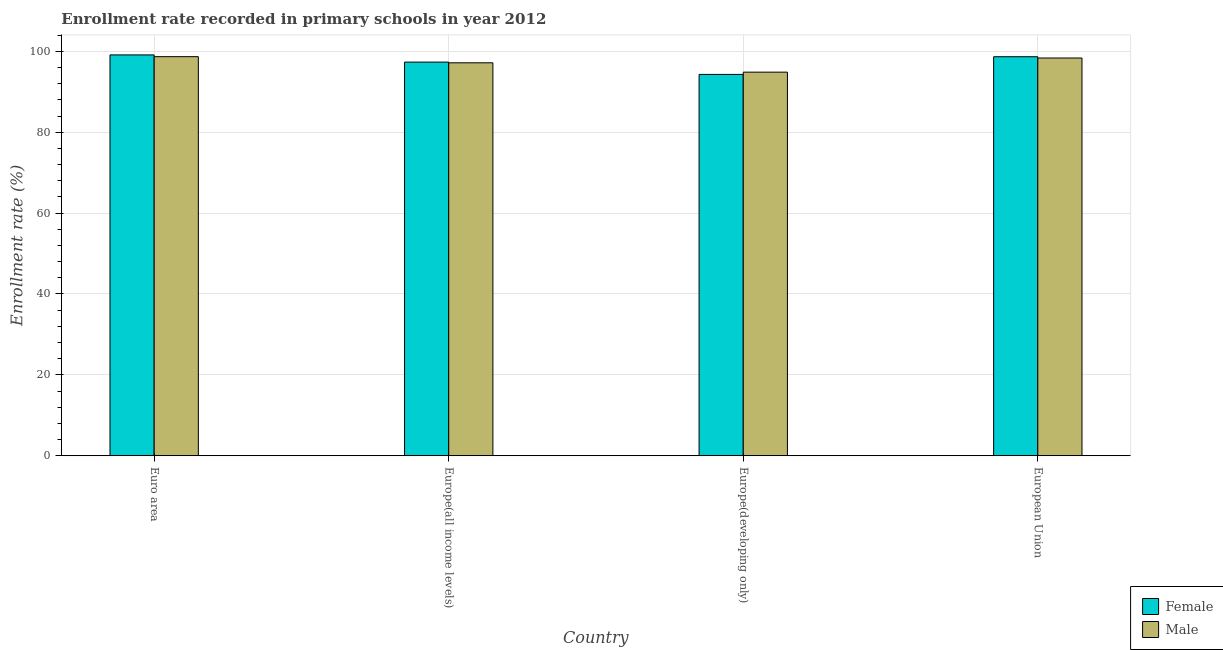How many different coloured bars are there?
Provide a succinct answer. 2. How many groups of bars are there?
Offer a terse response. 4. Are the number of bars per tick equal to the number of legend labels?
Your answer should be compact. Yes. How many bars are there on the 4th tick from the left?
Provide a succinct answer. 2. How many bars are there on the 2nd tick from the right?
Provide a short and direct response. 2. What is the label of the 2nd group of bars from the left?
Provide a short and direct response. Europe(all income levels). What is the enrollment rate of female students in Europe(all income levels)?
Make the answer very short. 97.34. Across all countries, what is the maximum enrollment rate of male students?
Your response must be concise. 98.68. Across all countries, what is the minimum enrollment rate of female students?
Your answer should be very brief. 94.29. In which country was the enrollment rate of female students minimum?
Your answer should be very brief. Europe(developing only). What is the total enrollment rate of female students in the graph?
Ensure brevity in your answer.  389.42. What is the difference between the enrollment rate of female students in Euro area and that in Europe(all income levels)?
Offer a very short reply. 1.78. What is the difference between the enrollment rate of male students in European Union and the enrollment rate of female students in Europe(all income levels)?
Your answer should be very brief. 1.01. What is the average enrollment rate of female students per country?
Your answer should be compact. 97.35. What is the difference between the enrollment rate of male students and enrollment rate of female students in Europe(developing only)?
Give a very brief answer. 0.56. What is the ratio of the enrollment rate of female students in Europe(all income levels) to that in Europe(developing only)?
Give a very brief answer. 1.03. Is the difference between the enrollment rate of female students in Euro area and Europe(developing only) greater than the difference between the enrollment rate of male students in Euro area and Europe(developing only)?
Keep it short and to the point. Yes. What is the difference between the highest and the second highest enrollment rate of female students?
Your answer should be very brief. 0.45. What is the difference between the highest and the lowest enrollment rate of female students?
Your answer should be very brief. 4.82. How many bars are there?
Make the answer very short. 8. Are all the bars in the graph horizontal?
Your response must be concise. No. How many countries are there in the graph?
Offer a terse response. 4. How many legend labels are there?
Ensure brevity in your answer.  2. What is the title of the graph?
Your answer should be very brief. Enrollment rate recorded in primary schools in year 2012. Does "Subsidies" appear as one of the legend labels in the graph?
Give a very brief answer. No. What is the label or title of the Y-axis?
Give a very brief answer. Enrollment rate (%). What is the Enrollment rate (%) of Female in Euro area?
Make the answer very short. 99.12. What is the Enrollment rate (%) in Male in Euro area?
Keep it short and to the point. 98.68. What is the Enrollment rate (%) of Female in Europe(all income levels)?
Your answer should be very brief. 97.34. What is the Enrollment rate (%) of Male in Europe(all income levels)?
Make the answer very short. 97.16. What is the Enrollment rate (%) in Female in Europe(developing only)?
Give a very brief answer. 94.29. What is the Enrollment rate (%) of Male in Europe(developing only)?
Your response must be concise. 94.85. What is the Enrollment rate (%) of Female in European Union?
Your answer should be very brief. 98.67. What is the Enrollment rate (%) in Male in European Union?
Keep it short and to the point. 98.35. Across all countries, what is the maximum Enrollment rate (%) of Female?
Your answer should be compact. 99.12. Across all countries, what is the maximum Enrollment rate (%) of Male?
Provide a short and direct response. 98.68. Across all countries, what is the minimum Enrollment rate (%) in Female?
Keep it short and to the point. 94.29. Across all countries, what is the minimum Enrollment rate (%) in Male?
Provide a short and direct response. 94.85. What is the total Enrollment rate (%) of Female in the graph?
Make the answer very short. 389.42. What is the total Enrollment rate (%) in Male in the graph?
Offer a terse response. 389.05. What is the difference between the Enrollment rate (%) of Female in Euro area and that in Europe(all income levels)?
Ensure brevity in your answer.  1.78. What is the difference between the Enrollment rate (%) of Male in Euro area and that in Europe(all income levels)?
Provide a short and direct response. 1.52. What is the difference between the Enrollment rate (%) in Female in Euro area and that in Europe(developing only)?
Keep it short and to the point. 4.82. What is the difference between the Enrollment rate (%) of Male in Euro area and that in Europe(developing only)?
Provide a short and direct response. 3.83. What is the difference between the Enrollment rate (%) in Female in Euro area and that in European Union?
Offer a very short reply. 0.45. What is the difference between the Enrollment rate (%) in Male in Euro area and that in European Union?
Provide a short and direct response. 0.33. What is the difference between the Enrollment rate (%) of Female in Europe(all income levels) and that in Europe(developing only)?
Offer a very short reply. 3.05. What is the difference between the Enrollment rate (%) in Male in Europe(all income levels) and that in Europe(developing only)?
Ensure brevity in your answer.  2.31. What is the difference between the Enrollment rate (%) in Female in Europe(all income levels) and that in European Union?
Offer a terse response. -1.33. What is the difference between the Enrollment rate (%) in Male in Europe(all income levels) and that in European Union?
Give a very brief answer. -1.19. What is the difference between the Enrollment rate (%) in Female in Europe(developing only) and that in European Union?
Make the answer very short. -4.38. What is the difference between the Enrollment rate (%) in Male in Europe(developing only) and that in European Union?
Your answer should be compact. -3.5. What is the difference between the Enrollment rate (%) of Female in Euro area and the Enrollment rate (%) of Male in Europe(all income levels)?
Your answer should be compact. 1.95. What is the difference between the Enrollment rate (%) of Female in Euro area and the Enrollment rate (%) of Male in Europe(developing only)?
Your answer should be compact. 4.26. What is the difference between the Enrollment rate (%) of Female in Euro area and the Enrollment rate (%) of Male in European Union?
Your answer should be compact. 0.76. What is the difference between the Enrollment rate (%) of Female in Europe(all income levels) and the Enrollment rate (%) of Male in Europe(developing only)?
Provide a short and direct response. 2.49. What is the difference between the Enrollment rate (%) of Female in Europe(all income levels) and the Enrollment rate (%) of Male in European Union?
Provide a succinct answer. -1.01. What is the difference between the Enrollment rate (%) in Female in Europe(developing only) and the Enrollment rate (%) in Male in European Union?
Offer a terse response. -4.06. What is the average Enrollment rate (%) in Female per country?
Ensure brevity in your answer.  97.35. What is the average Enrollment rate (%) in Male per country?
Your answer should be compact. 97.26. What is the difference between the Enrollment rate (%) in Female and Enrollment rate (%) in Male in Euro area?
Keep it short and to the point. 0.43. What is the difference between the Enrollment rate (%) of Female and Enrollment rate (%) of Male in Europe(all income levels)?
Your answer should be compact. 0.18. What is the difference between the Enrollment rate (%) in Female and Enrollment rate (%) in Male in Europe(developing only)?
Provide a succinct answer. -0.56. What is the difference between the Enrollment rate (%) of Female and Enrollment rate (%) of Male in European Union?
Your answer should be very brief. 0.32. What is the ratio of the Enrollment rate (%) of Female in Euro area to that in Europe(all income levels)?
Offer a terse response. 1.02. What is the ratio of the Enrollment rate (%) of Male in Euro area to that in Europe(all income levels)?
Provide a succinct answer. 1.02. What is the ratio of the Enrollment rate (%) in Female in Euro area to that in Europe(developing only)?
Offer a very short reply. 1.05. What is the ratio of the Enrollment rate (%) of Male in Euro area to that in Europe(developing only)?
Give a very brief answer. 1.04. What is the ratio of the Enrollment rate (%) in Female in Euro area to that in European Union?
Your answer should be compact. 1. What is the ratio of the Enrollment rate (%) of Male in Euro area to that in European Union?
Offer a terse response. 1. What is the ratio of the Enrollment rate (%) in Female in Europe(all income levels) to that in Europe(developing only)?
Ensure brevity in your answer.  1.03. What is the ratio of the Enrollment rate (%) of Male in Europe(all income levels) to that in Europe(developing only)?
Your answer should be compact. 1.02. What is the ratio of the Enrollment rate (%) in Female in Europe(all income levels) to that in European Union?
Provide a succinct answer. 0.99. What is the ratio of the Enrollment rate (%) of Male in Europe(all income levels) to that in European Union?
Ensure brevity in your answer.  0.99. What is the ratio of the Enrollment rate (%) of Female in Europe(developing only) to that in European Union?
Your response must be concise. 0.96. What is the ratio of the Enrollment rate (%) of Male in Europe(developing only) to that in European Union?
Provide a short and direct response. 0.96. What is the difference between the highest and the second highest Enrollment rate (%) in Female?
Your response must be concise. 0.45. What is the difference between the highest and the second highest Enrollment rate (%) of Male?
Make the answer very short. 0.33. What is the difference between the highest and the lowest Enrollment rate (%) in Female?
Offer a very short reply. 4.82. What is the difference between the highest and the lowest Enrollment rate (%) in Male?
Offer a terse response. 3.83. 